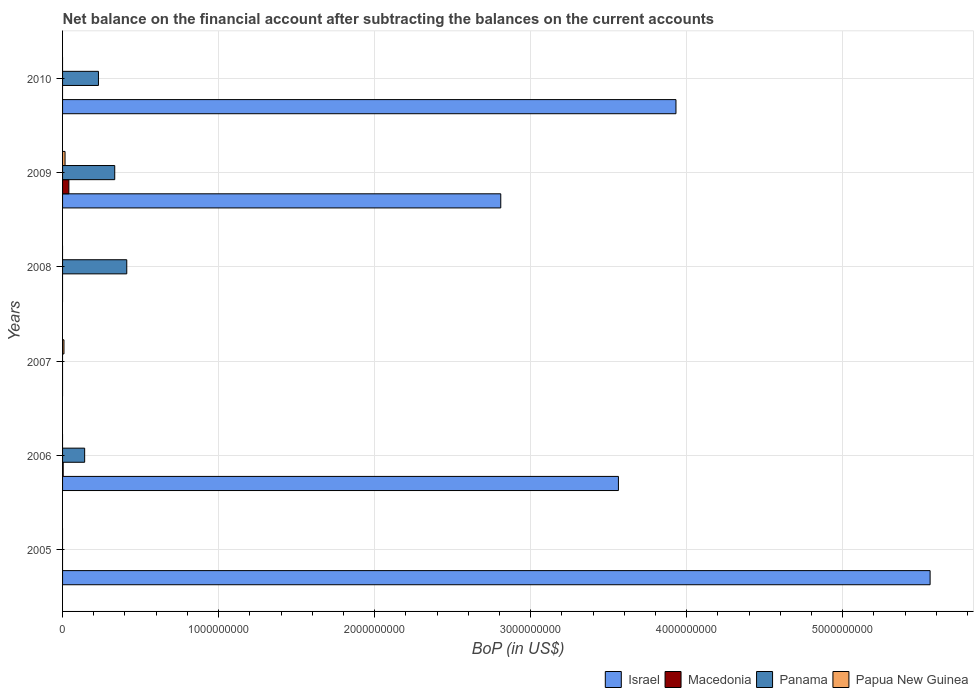Are the number of bars per tick equal to the number of legend labels?
Offer a very short reply. No. Are the number of bars on each tick of the Y-axis equal?
Provide a succinct answer. No. How many bars are there on the 5th tick from the top?
Your response must be concise. 3. What is the label of the 2nd group of bars from the top?
Provide a succinct answer. 2009. In how many cases, is the number of bars for a given year not equal to the number of legend labels?
Provide a succinct answer. 5. What is the Balance of Payments in Panama in 2010?
Make the answer very short. 2.30e+08. Across all years, what is the maximum Balance of Payments in Papua New Guinea?
Offer a very short reply. 1.59e+07. Across all years, what is the minimum Balance of Payments in Macedonia?
Provide a succinct answer. 0. In which year was the Balance of Payments in Papua New Guinea maximum?
Offer a very short reply. 2009. What is the total Balance of Payments in Panama in the graph?
Offer a terse response. 1.12e+09. What is the difference between the Balance of Payments in Israel in 2006 and that in 2009?
Keep it short and to the point. 7.54e+08. What is the difference between the Balance of Payments in Macedonia in 2010 and the Balance of Payments in Panama in 2009?
Make the answer very short. -3.34e+08. What is the average Balance of Payments in Panama per year?
Offer a terse response. 1.86e+08. In the year 2006, what is the difference between the Balance of Payments in Macedonia and Balance of Payments in Israel?
Provide a succinct answer. -3.56e+09. What is the ratio of the Balance of Payments in Panama in 2006 to that in 2008?
Make the answer very short. 0.34. Is the Balance of Payments in Israel in 2005 less than that in 2010?
Your answer should be very brief. No. What is the difference between the highest and the second highest Balance of Payments in Panama?
Offer a terse response. 7.71e+07. What is the difference between the highest and the lowest Balance of Payments in Panama?
Your answer should be compact. 4.12e+08. In how many years, is the Balance of Payments in Papua New Guinea greater than the average Balance of Payments in Papua New Guinea taken over all years?
Offer a terse response. 2. Is the sum of the Balance of Payments in Israel in 2006 and 2009 greater than the maximum Balance of Payments in Papua New Guinea across all years?
Keep it short and to the point. Yes. Is it the case that in every year, the sum of the Balance of Payments in Israel and Balance of Payments in Panama is greater than the sum of Balance of Payments in Macedonia and Balance of Payments in Papua New Guinea?
Provide a succinct answer. No. How many bars are there?
Give a very brief answer. 12. Are all the bars in the graph horizontal?
Your answer should be compact. Yes. How many years are there in the graph?
Your answer should be very brief. 6. Are the values on the major ticks of X-axis written in scientific E-notation?
Provide a short and direct response. No. Does the graph contain any zero values?
Your answer should be very brief. Yes. Where does the legend appear in the graph?
Your response must be concise. Bottom right. How many legend labels are there?
Give a very brief answer. 4. What is the title of the graph?
Ensure brevity in your answer.  Net balance on the financial account after subtracting the balances on the current accounts. What is the label or title of the X-axis?
Provide a short and direct response. BoP (in US$). What is the BoP (in US$) of Israel in 2005?
Your response must be concise. 5.56e+09. What is the BoP (in US$) in Panama in 2005?
Provide a short and direct response. 0. What is the BoP (in US$) of Papua New Guinea in 2005?
Your response must be concise. 0. What is the BoP (in US$) in Israel in 2006?
Offer a terse response. 3.56e+09. What is the BoP (in US$) of Macedonia in 2006?
Offer a terse response. 3.96e+06. What is the BoP (in US$) of Panama in 2006?
Offer a very short reply. 1.42e+08. What is the BoP (in US$) in Israel in 2007?
Ensure brevity in your answer.  0. What is the BoP (in US$) in Macedonia in 2007?
Your answer should be very brief. 0. What is the BoP (in US$) in Papua New Guinea in 2007?
Offer a terse response. 9.00e+06. What is the BoP (in US$) of Israel in 2008?
Provide a short and direct response. 0. What is the BoP (in US$) in Panama in 2008?
Your response must be concise. 4.12e+08. What is the BoP (in US$) in Israel in 2009?
Provide a short and direct response. 2.81e+09. What is the BoP (in US$) of Macedonia in 2009?
Provide a short and direct response. 4.04e+07. What is the BoP (in US$) of Panama in 2009?
Provide a short and direct response. 3.34e+08. What is the BoP (in US$) in Papua New Guinea in 2009?
Provide a short and direct response. 1.59e+07. What is the BoP (in US$) of Israel in 2010?
Offer a very short reply. 3.93e+09. What is the BoP (in US$) in Macedonia in 2010?
Give a very brief answer. 0. What is the BoP (in US$) in Panama in 2010?
Your response must be concise. 2.30e+08. What is the BoP (in US$) of Papua New Guinea in 2010?
Give a very brief answer. 0. Across all years, what is the maximum BoP (in US$) of Israel?
Keep it short and to the point. 5.56e+09. Across all years, what is the maximum BoP (in US$) of Macedonia?
Ensure brevity in your answer.  4.04e+07. Across all years, what is the maximum BoP (in US$) in Panama?
Offer a terse response. 4.12e+08. Across all years, what is the maximum BoP (in US$) of Papua New Guinea?
Provide a succinct answer. 1.59e+07. Across all years, what is the minimum BoP (in US$) of Israel?
Your answer should be compact. 0. Across all years, what is the minimum BoP (in US$) in Macedonia?
Your answer should be compact. 0. Across all years, what is the minimum BoP (in US$) in Panama?
Your answer should be compact. 0. Across all years, what is the minimum BoP (in US$) of Papua New Guinea?
Provide a succinct answer. 0. What is the total BoP (in US$) in Israel in the graph?
Keep it short and to the point. 1.59e+1. What is the total BoP (in US$) of Macedonia in the graph?
Your answer should be very brief. 4.43e+07. What is the total BoP (in US$) of Panama in the graph?
Your answer should be very brief. 1.12e+09. What is the total BoP (in US$) of Papua New Guinea in the graph?
Keep it short and to the point. 2.49e+07. What is the difference between the BoP (in US$) in Israel in 2005 and that in 2006?
Keep it short and to the point. 2.00e+09. What is the difference between the BoP (in US$) in Israel in 2005 and that in 2009?
Provide a short and direct response. 2.75e+09. What is the difference between the BoP (in US$) of Israel in 2005 and that in 2010?
Keep it short and to the point. 1.63e+09. What is the difference between the BoP (in US$) of Panama in 2006 and that in 2008?
Provide a short and direct response. -2.70e+08. What is the difference between the BoP (in US$) of Israel in 2006 and that in 2009?
Your answer should be compact. 7.54e+08. What is the difference between the BoP (in US$) in Macedonia in 2006 and that in 2009?
Provide a short and direct response. -3.64e+07. What is the difference between the BoP (in US$) of Panama in 2006 and that in 2009?
Offer a very short reply. -1.93e+08. What is the difference between the BoP (in US$) in Israel in 2006 and that in 2010?
Your answer should be very brief. -3.69e+08. What is the difference between the BoP (in US$) in Panama in 2006 and that in 2010?
Make the answer very short. -8.84e+07. What is the difference between the BoP (in US$) of Papua New Guinea in 2007 and that in 2009?
Your response must be concise. -6.86e+06. What is the difference between the BoP (in US$) in Panama in 2008 and that in 2009?
Provide a short and direct response. 7.71e+07. What is the difference between the BoP (in US$) of Panama in 2008 and that in 2010?
Provide a short and direct response. 1.82e+08. What is the difference between the BoP (in US$) in Israel in 2009 and that in 2010?
Ensure brevity in your answer.  -1.12e+09. What is the difference between the BoP (in US$) of Panama in 2009 and that in 2010?
Make the answer very short. 1.04e+08. What is the difference between the BoP (in US$) of Israel in 2005 and the BoP (in US$) of Macedonia in 2006?
Offer a terse response. 5.56e+09. What is the difference between the BoP (in US$) in Israel in 2005 and the BoP (in US$) in Panama in 2006?
Make the answer very short. 5.42e+09. What is the difference between the BoP (in US$) of Israel in 2005 and the BoP (in US$) of Papua New Guinea in 2007?
Your answer should be compact. 5.55e+09. What is the difference between the BoP (in US$) of Israel in 2005 and the BoP (in US$) of Panama in 2008?
Your answer should be very brief. 5.15e+09. What is the difference between the BoP (in US$) of Israel in 2005 and the BoP (in US$) of Macedonia in 2009?
Give a very brief answer. 5.52e+09. What is the difference between the BoP (in US$) of Israel in 2005 and the BoP (in US$) of Panama in 2009?
Keep it short and to the point. 5.23e+09. What is the difference between the BoP (in US$) of Israel in 2005 and the BoP (in US$) of Papua New Guinea in 2009?
Make the answer very short. 5.54e+09. What is the difference between the BoP (in US$) in Israel in 2005 and the BoP (in US$) in Panama in 2010?
Keep it short and to the point. 5.33e+09. What is the difference between the BoP (in US$) of Israel in 2006 and the BoP (in US$) of Papua New Guinea in 2007?
Provide a succinct answer. 3.55e+09. What is the difference between the BoP (in US$) of Macedonia in 2006 and the BoP (in US$) of Papua New Guinea in 2007?
Your response must be concise. -5.04e+06. What is the difference between the BoP (in US$) in Panama in 2006 and the BoP (in US$) in Papua New Guinea in 2007?
Offer a terse response. 1.33e+08. What is the difference between the BoP (in US$) of Israel in 2006 and the BoP (in US$) of Panama in 2008?
Your answer should be very brief. 3.15e+09. What is the difference between the BoP (in US$) of Macedonia in 2006 and the BoP (in US$) of Panama in 2008?
Make the answer very short. -4.08e+08. What is the difference between the BoP (in US$) in Israel in 2006 and the BoP (in US$) in Macedonia in 2009?
Provide a short and direct response. 3.52e+09. What is the difference between the BoP (in US$) in Israel in 2006 and the BoP (in US$) in Panama in 2009?
Ensure brevity in your answer.  3.23e+09. What is the difference between the BoP (in US$) in Israel in 2006 and the BoP (in US$) in Papua New Guinea in 2009?
Offer a very short reply. 3.55e+09. What is the difference between the BoP (in US$) of Macedonia in 2006 and the BoP (in US$) of Panama in 2009?
Give a very brief answer. -3.30e+08. What is the difference between the BoP (in US$) in Macedonia in 2006 and the BoP (in US$) in Papua New Guinea in 2009?
Keep it short and to the point. -1.19e+07. What is the difference between the BoP (in US$) of Panama in 2006 and the BoP (in US$) of Papua New Guinea in 2009?
Offer a terse response. 1.26e+08. What is the difference between the BoP (in US$) in Israel in 2006 and the BoP (in US$) in Panama in 2010?
Provide a short and direct response. 3.33e+09. What is the difference between the BoP (in US$) in Macedonia in 2006 and the BoP (in US$) in Panama in 2010?
Provide a short and direct response. -2.26e+08. What is the difference between the BoP (in US$) in Panama in 2008 and the BoP (in US$) in Papua New Guinea in 2009?
Keep it short and to the point. 3.96e+08. What is the difference between the BoP (in US$) of Israel in 2009 and the BoP (in US$) of Panama in 2010?
Keep it short and to the point. 2.58e+09. What is the difference between the BoP (in US$) of Macedonia in 2009 and the BoP (in US$) of Panama in 2010?
Your answer should be compact. -1.90e+08. What is the average BoP (in US$) in Israel per year?
Ensure brevity in your answer.  2.64e+09. What is the average BoP (in US$) in Macedonia per year?
Provide a succinct answer. 7.39e+06. What is the average BoP (in US$) of Panama per year?
Keep it short and to the point. 1.86e+08. What is the average BoP (in US$) of Papua New Guinea per year?
Provide a short and direct response. 4.14e+06. In the year 2006, what is the difference between the BoP (in US$) of Israel and BoP (in US$) of Macedonia?
Your answer should be very brief. 3.56e+09. In the year 2006, what is the difference between the BoP (in US$) in Israel and BoP (in US$) in Panama?
Give a very brief answer. 3.42e+09. In the year 2006, what is the difference between the BoP (in US$) in Macedonia and BoP (in US$) in Panama?
Give a very brief answer. -1.38e+08. In the year 2009, what is the difference between the BoP (in US$) in Israel and BoP (in US$) in Macedonia?
Offer a terse response. 2.77e+09. In the year 2009, what is the difference between the BoP (in US$) of Israel and BoP (in US$) of Panama?
Ensure brevity in your answer.  2.47e+09. In the year 2009, what is the difference between the BoP (in US$) in Israel and BoP (in US$) in Papua New Guinea?
Give a very brief answer. 2.79e+09. In the year 2009, what is the difference between the BoP (in US$) in Macedonia and BoP (in US$) in Panama?
Give a very brief answer. -2.94e+08. In the year 2009, what is the difference between the BoP (in US$) in Macedonia and BoP (in US$) in Papua New Guinea?
Your response must be concise. 2.45e+07. In the year 2009, what is the difference between the BoP (in US$) in Panama and BoP (in US$) in Papua New Guinea?
Give a very brief answer. 3.19e+08. In the year 2010, what is the difference between the BoP (in US$) in Israel and BoP (in US$) in Panama?
Provide a succinct answer. 3.70e+09. What is the ratio of the BoP (in US$) in Israel in 2005 to that in 2006?
Provide a short and direct response. 1.56. What is the ratio of the BoP (in US$) in Israel in 2005 to that in 2009?
Make the answer very short. 1.98. What is the ratio of the BoP (in US$) of Israel in 2005 to that in 2010?
Offer a very short reply. 1.41. What is the ratio of the BoP (in US$) of Panama in 2006 to that in 2008?
Give a very brief answer. 0.34. What is the ratio of the BoP (in US$) in Israel in 2006 to that in 2009?
Offer a terse response. 1.27. What is the ratio of the BoP (in US$) in Macedonia in 2006 to that in 2009?
Provide a succinct answer. 0.1. What is the ratio of the BoP (in US$) of Panama in 2006 to that in 2009?
Offer a terse response. 0.42. What is the ratio of the BoP (in US$) in Israel in 2006 to that in 2010?
Your answer should be very brief. 0.91. What is the ratio of the BoP (in US$) in Panama in 2006 to that in 2010?
Provide a short and direct response. 0.62. What is the ratio of the BoP (in US$) in Papua New Guinea in 2007 to that in 2009?
Provide a short and direct response. 0.57. What is the ratio of the BoP (in US$) in Panama in 2008 to that in 2009?
Your answer should be compact. 1.23. What is the ratio of the BoP (in US$) in Panama in 2008 to that in 2010?
Provide a short and direct response. 1.79. What is the ratio of the BoP (in US$) in Israel in 2009 to that in 2010?
Ensure brevity in your answer.  0.71. What is the ratio of the BoP (in US$) in Panama in 2009 to that in 2010?
Provide a succinct answer. 1.45. What is the difference between the highest and the second highest BoP (in US$) of Israel?
Offer a very short reply. 1.63e+09. What is the difference between the highest and the second highest BoP (in US$) in Panama?
Offer a very short reply. 7.71e+07. What is the difference between the highest and the lowest BoP (in US$) of Israel?
Your answer should be compact. 5.56e+09. What is the difference between the highest and the lowest BoP (in US$) in Macedonia?
Provide a short and direct response. 4.04e+07. What is the difference between the highest and the lowest BoP (in US$) of Panama?
Make the answer very short. 4.12e+08. What is the difference between the highest and the lowest BoP (in US$) of Papua New Guinea?
Make the answer very short. 1.59e+07. 